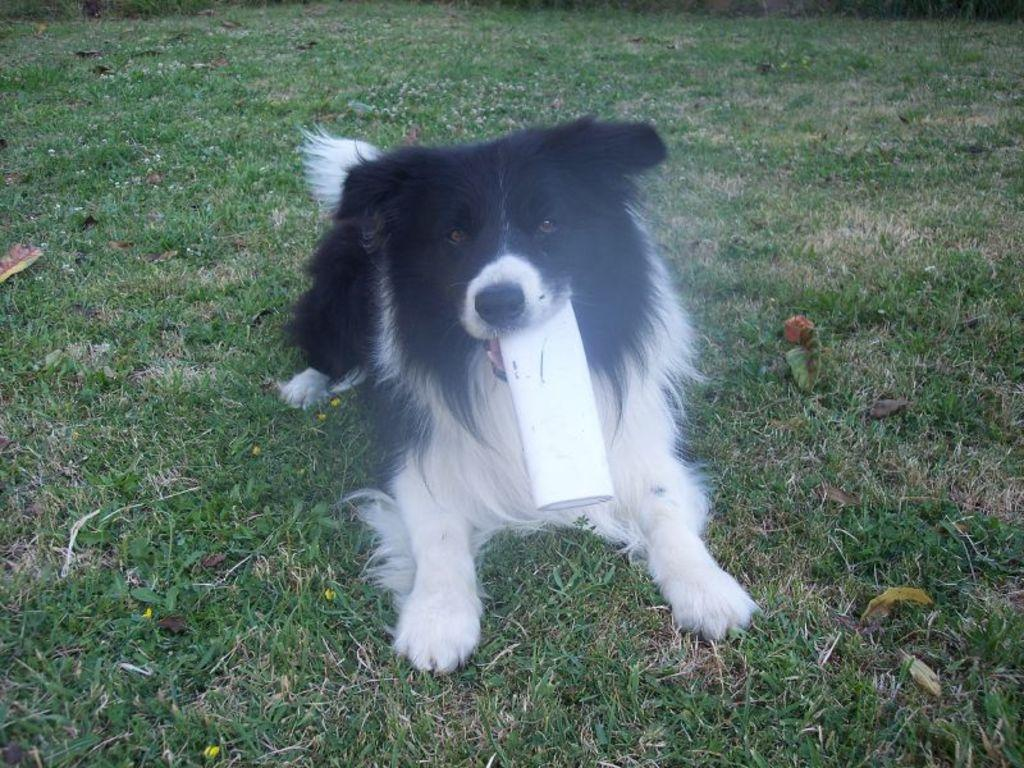What is the main subject in the foreground of the image? There is a dog in the foreground of the image. What is the dog doing in the image? The dog is holding an object in its mouth. Where is the object located in the image? The object is on the grass. How many houses can be seen in the background of the image? There are no houses visible in the image; it only features a dog holding an object on the grass. 